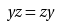<formula> <loc_0><loc_0><loc_500><loc_500>y z = z y</formula> 